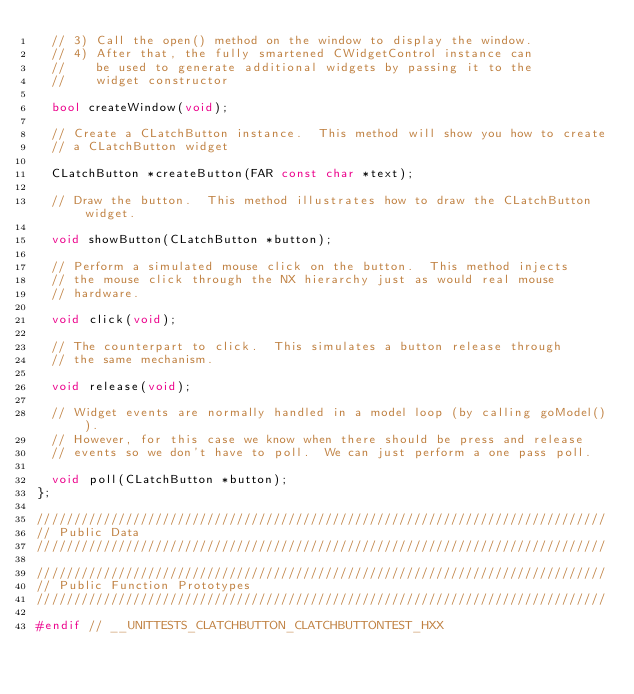<code> <loc_0><loc_0><loc_500><loc_500><_C++_>  // 3) Call the open() method on the window to display the window.
  // 4) After that, the fully smartened CWidgetControl instance can
  //    be used to generate additional widgets by passing it to the
  //    widget constructor

  bool createWindow(void);

  // Create a CLatchButton instance.  This method will show you how to create
  // a CLatchButton widget

  CLatchButton *createButton(FAR const char *text);

  // Draw the button.  This method illustrates how to draw the CLatchButton widget.

  void showButton(CLatchButton *button);

  // Perform a simulated mouse click on the button.  This method injects
  // the mouse click through the NX hierarchy just as would real mouse
  // hardware.

  void click(void);

  // The counterpart to click.  This simulates a button release through
  // the same mechanism.

  void release(void);

  // Widget events are normally handled in a model loop (by calling goModel()).
  // However, for this case we know when there should be press and release
  // events so we don't have to poll.  We can just perform a one pass poll.

  void poll(CLatchButton *button);
};

/////////////////////////////////////////////////////////////////////////////
// Public Data
/////////////////////////////////////////////////////////////////////////////

/////////////////////////////////////////////////////////////////////////////
// Public Function Prototypes
/////////////////////////////////////////////////////////////////////////////

#endif // __UNITTESTS_CLATCHBUTTON_CLATCHBUTTONTEST_HXX
</code> 